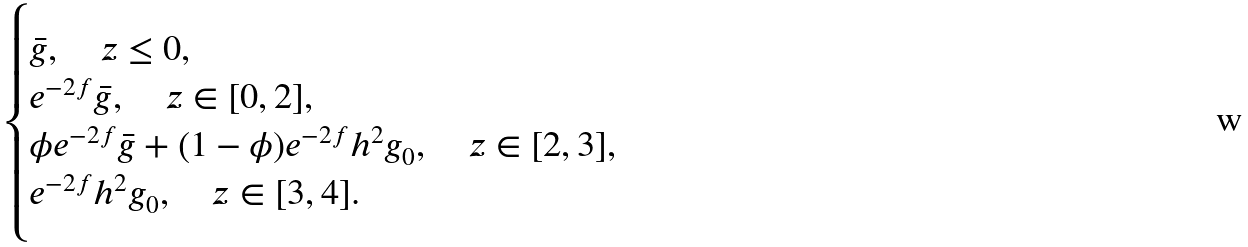<formula> <loc_0><loc_0><loc_500><loc_500>\begin{cases} \bar { g } , \quad z \leq 0 , \\ e ^ { - 2 f } \bar { g } , \quad z \in [ 0 , 2 ] , \\ \phi e ^ { - 2 f } \bar { g } + ( 1 - \phi ) e ^ { - 2 f } h ^ { 2 } g _ { 0 } , \quad z \in [ 2 , 3 ] , \\ e ^ { - 2 f } h ^ { 2 } g _ { 0 } , \quad z \in [ 3 , 4 ] . \end{cases}</formula> 